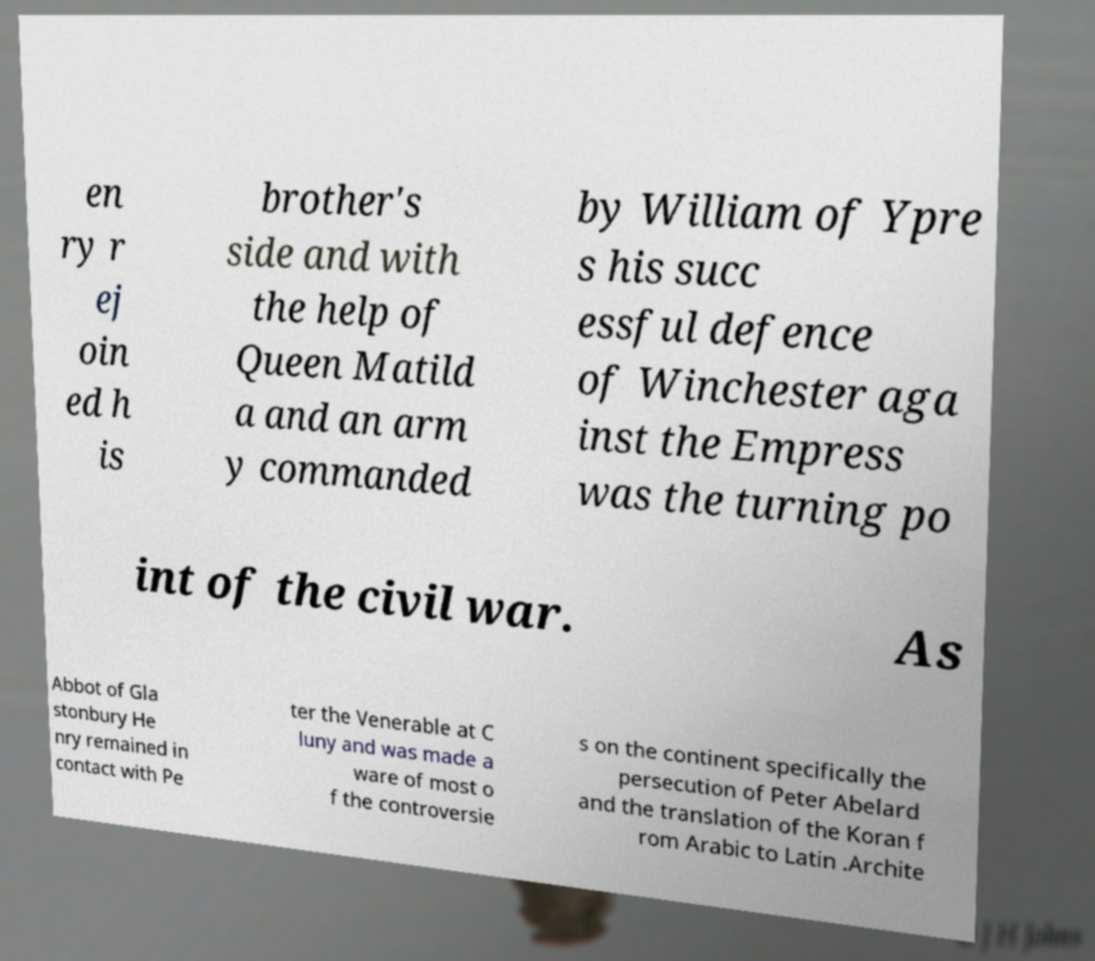Please identify and transcribe the text found in this image. en ry r ej oin ed h is brother's side and with the help of Queen Matild a and an arm y commanded by William of Ypre s his succ essful defence of Winchester aga inst the Empress was the turning po int of the civil war. As Abbot of Gla stonbury He nry remained in contact with Pe ter the Venerable at C luny and was made a ware of most o f the controversie s on the continent specifically the persecution of Peter Abelard and the translation of the Koran f rom Arabic to Latin .Archite 